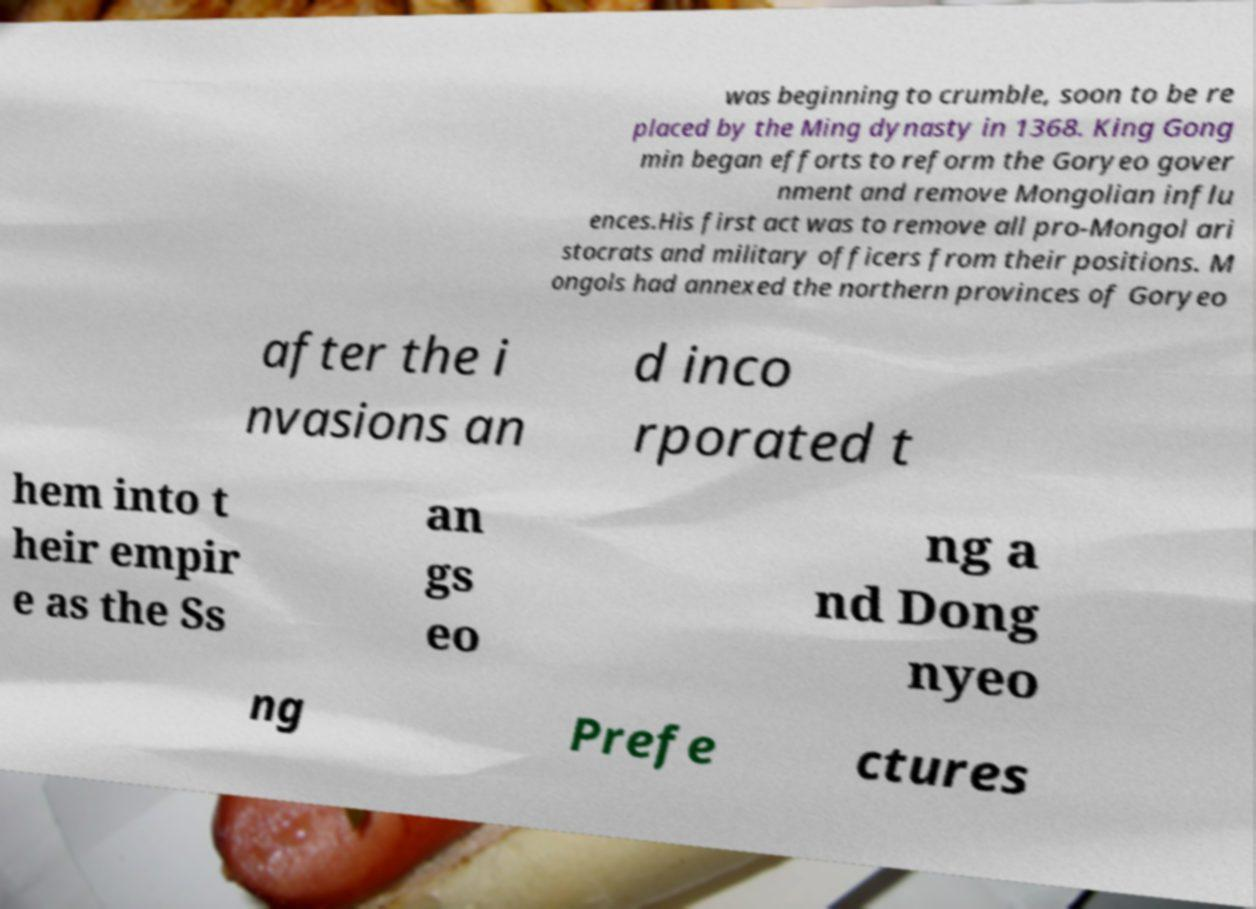Could you assist in decoding the text presented in this image and type it out clearly? was beginning to crumble, soon to be re placed by the Ming dynasty in 1368. King Gong min began efforts to reform the Goryeo gover nment and remove Mongolian influ ences.His first act was to remove all pro-Mongol ari stocrats and military officers from their positions. M ongols had annexed the northern provinces of Goryeo after the i nvasions an d inco rporated t hem into t heir empir e as the Ss an gs eo ng a nd Dong nyeo ng Prefe ctures 